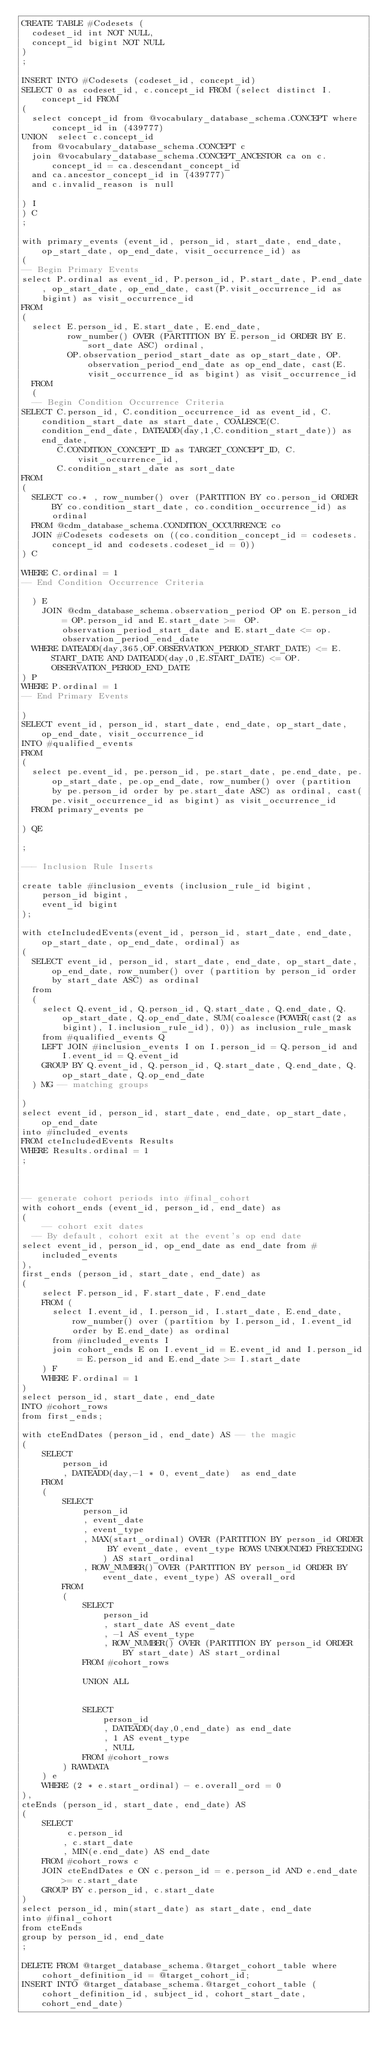<code> <loc_0><loc_0><loc_500><loc_500><_SQL_>CREATE TABLE #Codesets (
  codeset_id int NOT NULL,
  concept_id bigint NOT NULL
)
;

INSERT INTO #Codesets (codeset_id, concept_id)
SELECT 0 as codeset_id, c.concept_id FROM (select distinct I.concept_id FROM
( 
  select concept_id from @vocabulary_database_schema.CONCEPT where concept_id in (439777)
UNION  select c.concept_id
  from @vocabulary_database_schema.CONCEPT c
  join @vocabulary_database_schema.CONCEPT_ANCESTOR ca on c.concept_id = ca.descendant_concept_id
  and ca.ancestor_concept_id in (439777)
  and c.invalid_reason is null

) I
) C
;

with primary_events (event_id, person_id, start_date, end_date, op_start_date, op_end_date, visit_occurrence_id) as
(
-- Begin Primary Events
select P.ordinal as event_id, P.person_id, P.start_date, P.end_date, op_start_date, op_end_date, cast(P.visit_occurrence_id as bigint) as visit_occurrence_id
FROM
(
  select E.person_id, E.start_date, E.end_date,
         row_number() OVER (PARTITION BY E.person_id ORDER BY E.sort_date ASC) ordinal,
         OP.observation_period_start_date as op_start_date, OP.observation_period_end_date as op_end_date, cast(E.visit_occurrence_id as bigint) as visit_occurrence_id
  FROM 
  (
  -- Begin Condition Occurrence Criteria
SELECT C.person_id, C.condition_occurrence_id as event_id, C.condition_start_date as start_date, COALESCE(C.condition_end_date, DATEADD(day,1,C.condition_start_date)) as end_date,
       C.CONDITION_CONCEPT_ID as TARGET_CONCEPT_ID, C.visit_occurrence_id,
       C.condition_start_date as sort_date
FROM 
(
  SELECT co.* , row_number() over (PARTITION BY co.person_id ORDER BY co.condition_start_date, co.condition_occurrence_id) as ordinal
  FROM @cdm_database_schema.CONDITION_OCCURRENCE co
  JOIN #Codesets codesets on ((co.condition_concept_id = codesets.concept_id and codesets.codeset_id = 0))
) C

WHERE C.ordinal = 1
-- End Condition Occurrence Criteria

  ) E
	JOIN @cdm_database_schema.observation_period OP on E.person_id = OP.person_id and E.start_date >=  OP.observation_period_start_date and E.start_date <= op.observation_period_end_date
  WHERE DATEADD(day,365,OP.OBSERVATION_PERIOD_START_DATE) <= E.START_DATE AND DATEADD(day,0,E.START_DATE) <= OP.OBSERVATION_PERIOD_END_DATE
) P
WHERE P.ordinal = 1
-- End Primary Events

)
SELECT event_id, person_id, start_date, end_date, op_start_date, op_end_date, visit_occurrence_id
INTO #qualified_events
FROM 
(
  select pe.event_id, pe.person_id, pe.start_date, pe.end_date, pe.op_start_date, pe.op_end_date, row_number() over (partition by pe.person_id order by pe.start_date ASC) as ordinal, cast(pe.visit_occurrence_id as bigint) as visit_occurrence_id
  FROM primary_events pe
  
) QE

;

--- Inclusion Rule Inserts

create table #inclusion_events (inclusion_rule_id bigint,
	person_id bigint,
	event_id bigint
);

with cteIncludedEvents(event_id, person_id, start_date, end_date, op_start_date, op_end_date, ordinal) as
(
  SELECT event_id, person_id, start_date, end_date, op_start_date, op_end_date, row_number() over (partition by person_id order by start_date ASC) as ordinal
  from
  (
    select Q.event_id, Q.person_id, Q.start_date, Q.end_date, Q.op_start_date, Q.op_end_date, SUM(coalesce(POWER(cast(2 as bigint), I.inclusion_rule_id), 0)) as inclusion_rule_mask
    from #qualified_events Q
    LEFT JOIN #inclusion_events I on I.person_id = Q.person_id and I.event_id = Q.event_id
    GROUP BY Q.event_id, Q.person_id, Q.start_date, Q.end_date, Q.op_start_date, Q.op_end_date
  ) MG -- matching groups

)
select event_id, person_id, start_date, end_date, op_start_date, op_end_date
into #included_events
FROM cteIncludedEvents Results
WHERE Results.ordinal = 1
;



-- generate cohort periods into #final_cohort
with cohort_ends (event_id, person_id, end_date) as
(
	-- cohort exit dates
  -- By default, cohort exit at the event's op end date
select event_id, person_id, op_end_date as end_date from #included_events
),
first_ends (person_id, start_date, end_date) as
(
	select F.person_id, F.start_date, F.end_date
	FROM (
	  select I.event_id, I.person_id, I.start_date, E.end_date, row_number() over (partition by I.person_id, I.event_id order by E.end_date) as ordinal 
	  from #included_events I
	  join cohort_ends E on I.event_id = E.event_id and I.person_id = E.person_id and E.end_date >= I.start_date
	) F
	WHERE F.ordinal = 1
)
select person_id, start_date, end_date
INTO #cohort_rows
from first_ends;

with cteEndDates (person_id, end_date) AS -- the magic
(	
	SELECT
		person_id
		, DATEADD(day,-1 * 0, event_date)  as end_date
	FROM
	(
		SELECT
			person_id
			, event_date
			, event_type
			, MAX(start_ordinal) OVER (PARTITION BY person_id ORDER BY event_date, event_type ROWS UNBOUNDED PRECEDING) AS start_ordinal 
			, ROW_NUMBER() OVER (PARTITION BY person_id ORDER BY event_date, event_type) AS overall_ord
		FROM
		(
			SELECT
				person_id
				, start_date AS event_date
				, -1 AS event_type
				, ROW_NUMBER() OVER (PARTITION BY person_id ORDER BY start_date) AS start_ordinal
			FROM #cohort_rows
		
			UNION ALL
		

			SELECT
				person_id
				, DATEADD(day,0,end_date) as end_date
				, 1 AS event_type
				, NULL
			FROM #cohort_rows
		) RAWDATA
	) e
	WHERE (2 * e.start_ordinal) - e.overall_ord = 0
),
cteEnds (person_id, start_date, end_date) AS
(
	SELECT
		 c.person_id
		, c.start_date
		, MIN(e.end_date) AS end_date
	FROM #cohort_rows c
	JOIN cteEndDates e ON c.person_id = e.person_id AND e.end_date >= c.start_date
	GROUP BY c.person_id, c.start_date
)
select person_id, min(start_date) as start_date, end_date
into #final_cohort
from cteEnds
group by person_id, end_date
;

DELETE FROM @target_database_schema.@target_cohort_table where cohort_definition_id = @target_cohort_id;
INSERT INTO @target_database_schema.@target_cohort_table (cohort_definition_id, subject_id, cohort_start_date, cohort_end_date)</code> 